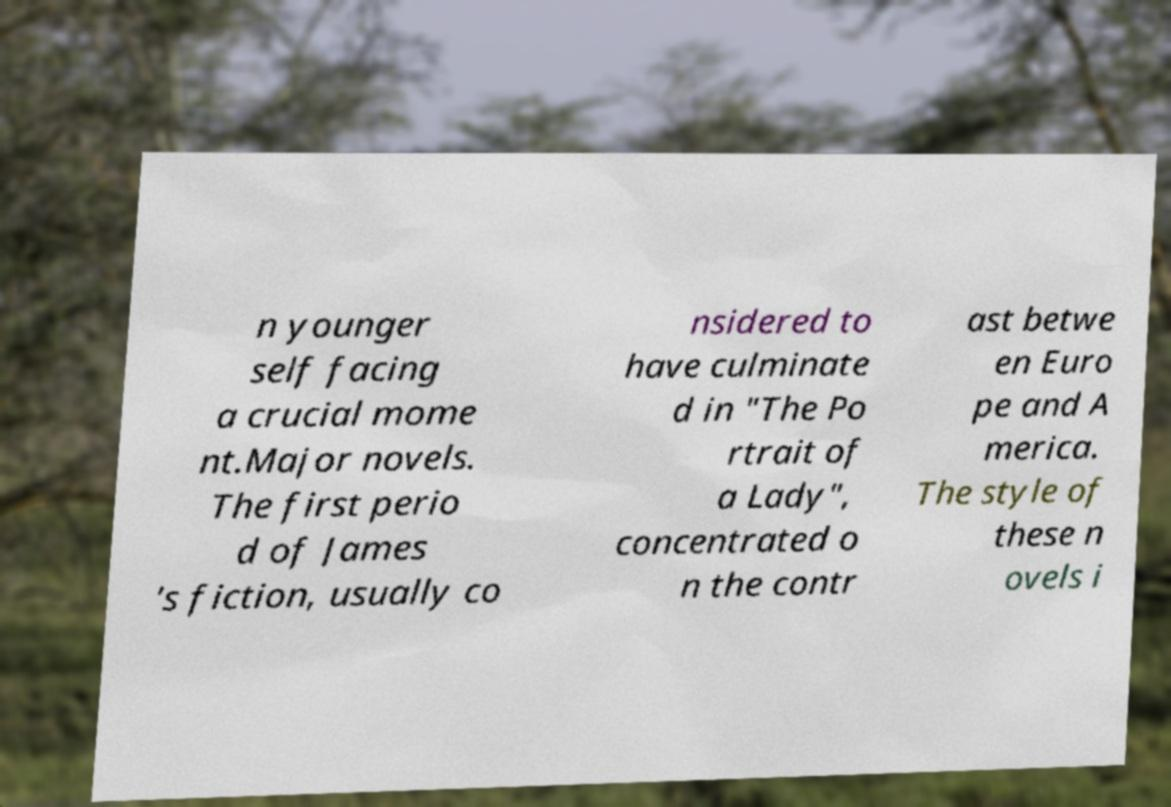Can you read and provide the text displayed in the image?This photo seems to have some interesting text. Can you extract and type it out for me? n younger self facing a crucial mome nt.Major novels. The first perio d of James 's fiction, usually co nsidered to have culminate d in "The Po rtrait of a Lady", concentrated o n the contr ast betwe en Euro pe and A merica. The style of these n ovels i 